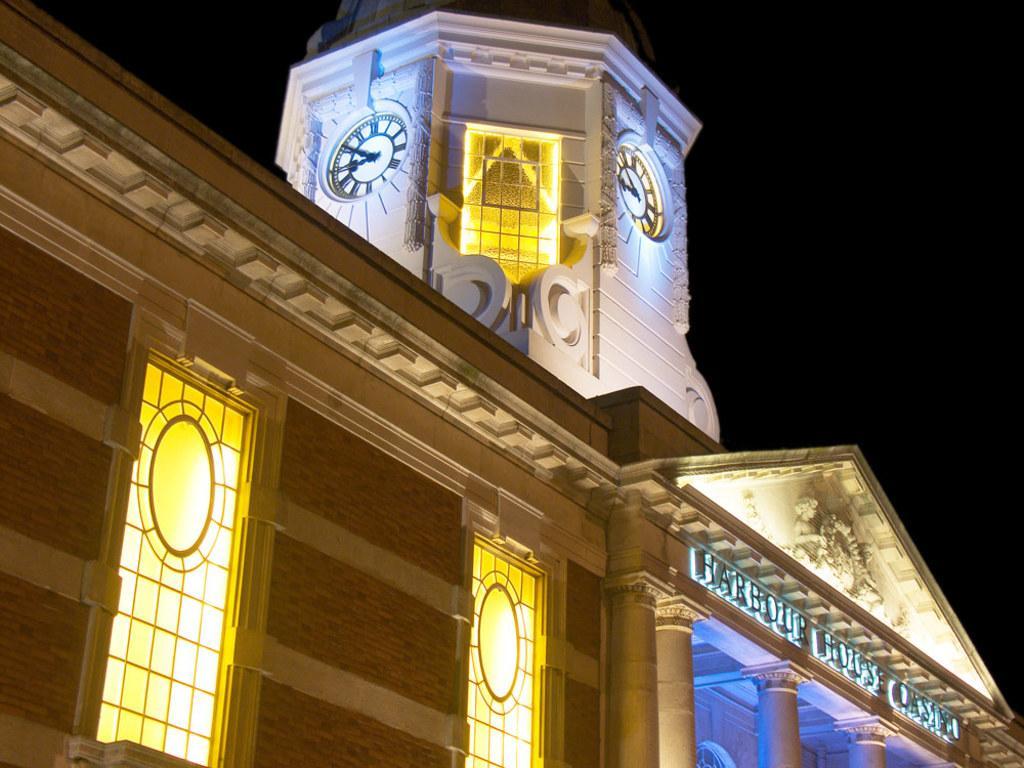Describe this image in one or two sentences. In this image there is a building with clocks and sculptures, and in the background there is sky. 